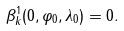<formula> <loc_0><loc_0><loc_500><loc_500>\beta _ { k } ^ { 1 } ( 0 , \varphi _ { 0 } , \lambda _ { 0 } ) = 0 .</formula> 